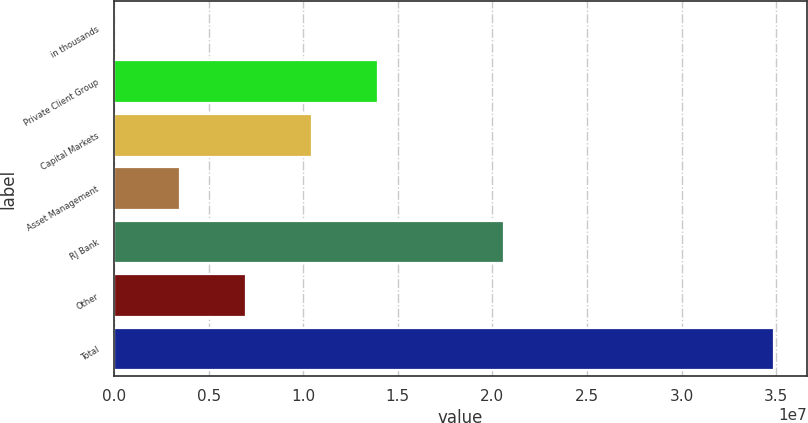Convert chart. <chart><loc_0><loc_0><loc_500><loc_500><bar_chart><fcel>in thousands<fcel>Private Client Group<fcel>Capital Markets<fcel>Asset Management<fcel>RJ Bank<fcel>Other<fcel>Total<nl><fcel>2017<fcel>1.39546e+07<fcel>1.04664e+07<fcel>3.49016e+06<fcel>2.06119e+07<fcel>6.9783e+06<fcel>3.48835e+07<nl></chart> 